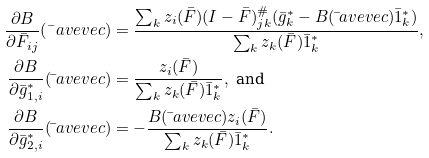<formula> <loc_0><loc_0><loc_500><loc_500>\frac { \partial B } { \partial \bar { F } _ { i j } } ( \bar { \ } a v e v e c ) & = \frac { \sum _ { k } z _ { i } ( \bar { F } ) ( I - \bar { F } ) ^ { \# } _ { j k } ( \bar { g } ^ { \ast } _ { k } - B ( \bar { \ } a v e v e c ) \bar { 1 } ^ { \ast } _ { k } ) } { \sum _ { k } z _ { k } ( \bar { F } ) \bar { 1 } ^ { \ast } _ { k } } , \\ \frac { \partial B } { \partial \bar { g } ^ { \ast } _ { 1 , i } } ( \bar { \ } a v e v e c ) & = \frac { z _ { i } ( \bar { F } ) } { \sum _ { k } z _ { k } ( \bar { F } ) \bar { 1 } _ { k } ^ { \ast } } , \text { and } \\ \frac { \partial B } { \partial \bar { g } ^ { \ast } _ { 2 , i } } ( \bar { \ } a v e v e c ) & = - \frac { B ( \bar { \ } a v e v e c ) z _ { i } ( \bar { F } ) } { \sum _ { k } z _ { k } ( \bar { F } ) \bar { 1 } _ { k } ^ { \ast } } .</formula> 